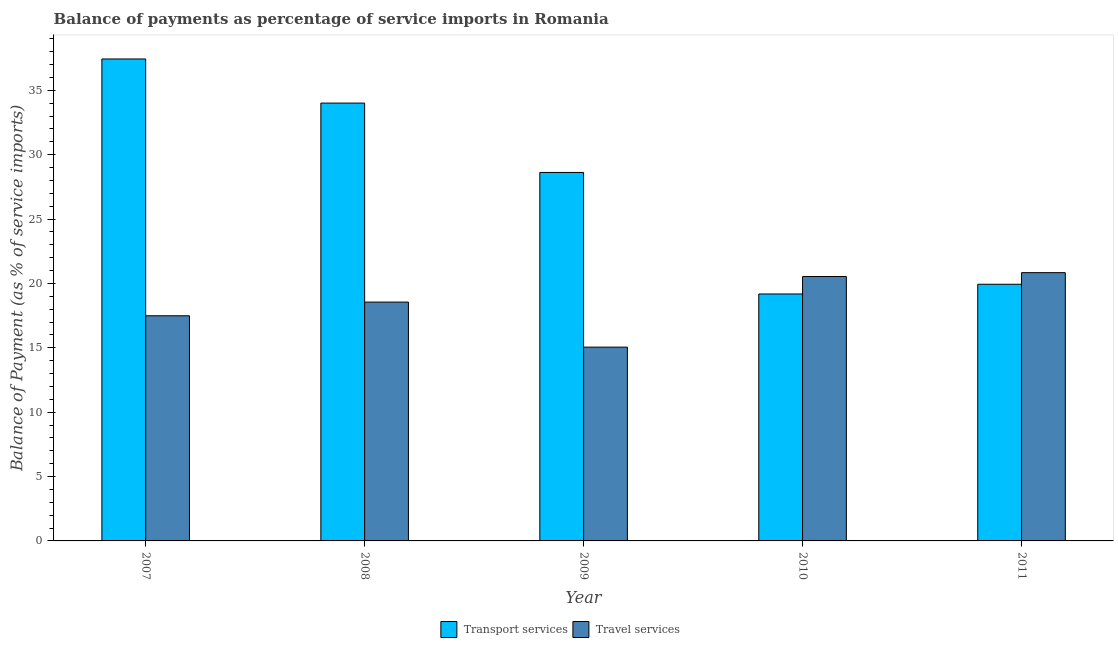How many different coloured bars are there?
Offer a very short reply. 2. How many groups of bars are there?
Offer a terse response. 5. Are the number of bars on each tick of the X-axis equal?
Make the answer very short. Yes. How many bars are there on the 4th tick from the left?
Keep it short and to the point. 2. How many bars are there on the 4th tick from the right?
Provide a short and direct response. 2. What is the label of the 5th group of bars from the left?
Provide a succinct answer. 2011. In how many cases, is the number of bars for a given year not equal to the number of legend labels?
Your answer should be very brief. 0. What is the balance of payments of transport services in 2011?
Provide a succinct answer. 19.94. Across all years, what is the maximum balance of payments of transport services?
Provide a short and direct response. 37.44. Across all years, what is the minimum balance of payments of travel services?
Offer a very short reply. 15.05. In which year was the balance of payments of travel services maximum?
Your answer should be compact. 2011. What is the total balance of payments of transport services in the graph?
Provide a short and direct response. 139.19. What is the difference between the balance of payments of travel services in 2008 and that in 2011?
Your answer should be very brief. -2.29. What is the difference between the balance of payments of transport services in 2010 and the balance of payments of travel services in 2009?
Your answer should be compact. -9.44. What is the average balance of payments of transport services per year?
Provide a short and direct response. 27.84. What is the ratio of the balance of payments of transport services in 2007 to that in 2011?
Your answer should be compact. 1.88. Is the difference between the balance of payments of travel services in 2008 and 2009 greater than the difference between the balance of payments of transport services in 2008 and 2009?
Offer a terse response. No. What is the difference between the highest and the second highest balance of payments of transport services?
Your answer should be very brief. 3.43. What is the difference between the highest and the lowest balance of payments of transport services?
Your answer should be very brief. 18.25. What does the 2nd bar from the left in 2011 represents?
Provide a short and direct response. Travel services. What does the 2nd bar from the right in 2009 represents?
Your response must be concise. Transport services. How many years are there in the graph?
Make the answer very short. 5. What is the difference between two consecutive major ticks on the Y-axis?
Ensure brevity in your answer.  5. Are the values on the major ticks of Y-axis written in scientific E-notation?
Ensure brevity in your answer.  No. Does the graph contain grids?
Your response must be concise. No. Where does the legend appear in the graph?
Provide a short and direct response. Bottom center. How are the legend labels stacked?
Provide a succinct answer. Horizontal. What is the title of the graph?
Make the answer very short. Balance of payments as percentage of service imports in Romania. What is the label or title of the X-axis?
Provide a short and direct response. Year. What is the label or title of the Y-axis?
Offer a terse response. Balance of Payment (as % of service imports). What is the Balance of Payment (as % of service imports) in Transport services in 2007?
Provide a short and direct response. 37.44. What is the Balance of Payment (as % of service imports) of Travel services in 2007?
Keep it short and to the point. 17.49. What is the Balance of Payment (as % of service imports) of Transport services in 2008?
Offer a terse response. 34.01. What is the Balance of Payment (as % of service imports) of Travel services in 2008?
Your answer should be very brief. 18.55. What is the Balance of Payment (as % of service imports) in Transport services in 2009?
Provide a short and direct response. 28.62. What is the Balance of Payment (as % of service imports) of Travel services in 2009?
Give a very brief answer. 15.05. What is the Balance of Payment (as % of service imports) of Transport services in 2010?
Your answer should be very brief. 19.18. What is the Balance of Payment (as % of service imports) of Travel services in 2010?
Give a very brief answer. 20.54. What is the Balance of Payment (as % of service imports) of Transport services in 2011?
Provide a succinct answer. 19.94. What is the Balance of Payment (as % of service imports) in Travel services in 2011?
Keep it short and to the point. 20.84. Across all years, what is the maximum Balance of Payment (as % of service imports) of Transport services?
Your response must be concise. 37.44. Across all years, what is the maximum Balance of Payment (as % of service imports) of Travel services?
Ensure brevity in your answer.  20.84. Across all years, what is the minimum Balance of Payment (as % of service imports) of Transport services?
Your response must be concise. 19.18. Across all years, what is the minimum Balance of Payment (as % of service imports) of Travel services?
Provide a short and direct response. 15.05. What is the total Balance of Payment (as % of service imports) in Transport services in the graph?
Keep it short and to the point. 139.19. What is the total Balance of Payment (as % of service imports) of Travel services in the graph?
Provide a succinct answer. 92.47. What is the difference between the Balance of Payment (as % of service imports) of Transport services in 2007 and that in 2008?
Keep it short and to the point. 3.43. What is the difference between the Balance of Payment (as % of service imports) of Travel services in 2007 and that in 2008?
Give a very brief answer. -1.06. What is the difference between the Balance of Payment (as % of service imports) of Transport services in 2007 and that in 2009?
Give a very brief answer. 8.81. What is the difference between the Balance of Payment (as % of service imports) in Travel services in 2007 and that in 2009?
Ensure brevity in your answer.  2.44. What is the difference between the Balance of Payment (as % of service imports) in Transport services in 2007 and that in 2010?
Offer a very short reply. 18.25. What is the difference between the Balance of Payment (as % of service imports) of Travel services in 2007 and that in 2010?
Make the answer very short. -3.05. What is the difference between the Balance of Payment (as % of service imports) in Transport services in 2007 and that in 2011?
Your answer should be compact. 17.5. What is the difference between the Balance of Payment (as % of service imports) of Travel services in 2007 and that in 2011?
Ensure brevity in your answer.  -3.35. What is the difference between the Balance of Payment (as % of service imports) of Transport services in 2008 and that in 2009?
Ensure brevity in your answer.  5.39. What is the difference between the Balance of Payment (as % of service imports) of Travel services in 2008 and that in 2009?
Your answer should be compact. 3.5. What is the difference between the Balance of Payment (as % of service imports) in Transport services in 2008 and that in 2010?
Offer a terse response. 14.83. What is the difference between the Balance of Payment (as % of service imports) of Travel services in 2008 and that in 2010?
Keep it short and to the point. -1.99. What is the difference between the Balance of Payment (as % of service imports) of Transport services in 2008 and that in 2011?
Your answer should be very brief. 14.07. What is the difference between the Balance of Payment (as % of service imports) of Travel services in 2008 and that in 2011?
Provide a succinct answer. -2.29. What is the difference between the Balance of Payment (as % of service imports) in Transport services in 2009 and that in 2010?
Provide a succinct answer. 9.44. What is the difference between the Balance of Payment (as % of service imports) of Travel services in 2009 and that in 2010?
Give a very brief answer. -5.48. What is the difference between the Balance of Payment (as % of service imports) of Transport services in 2009 and that in 2011?
Provide a succinct answer. 8.69. What is the difference between the Balance of Payment (as % of service imports) of Travel services in 2009 and that in 2011?
Give a very brief answer. -5.78. What is the difference between the Balance of Payment (as % of service imports) of Transport services in 2010 and that in 2011?
Provide a succinct answer. -0.75. What is the difference between the Balance of Payment (as % of service imports) of Travel services in 2010 and that in 2011?
Keep it short and to the point. -0.3. What is the difference between the Balance of Payment (as % of service imports) in Transport services in 2007 and the Balance of Payment (as % of service imports) in Travel services in 2008?
Offer a very short reply. 18.88. What is the difference between the Balance of Payment (as % of service imports) of Transport services in 2007 and the Balance of Payment (as % of service imports) of Travel services in 2009?
Keep it short and to the point. 22.38. What is the difference between the Balance of Payment (as % of service imports) in Transport services in 2007 and the Balance of Payment (as % of service imports) in Travel services in 2010?
Give a very brief answer. 16.9. What is the difference between the Balance of Payment (as % of service imports) in Transport services in 2007 and the Balance of Payment (as % of service imports) in Travel services in 2011?
Your response must be concise. 16.6. What is the difference between the Balance of Payment (as % of service imports) of Transport services in 2008 and the Balance of Payment (as % of service imports) of Travel services in 2009?
Offer a terse response. 18.96. What is the difference between the Balance of Payment (as % of service imports) in Transport services in 2008 and the Balance of Payment (as % of service imports) in Travel services in 2010?
Make the answer very short. 13.47. What is the difference between the Balance of Payment (as % of service imports) of Transport services in 2008 and the Balance of Payment (as % of service imports) of Travel services in 2011?
Offer a very short reply. 13.17. What is the difference between the Balance of Payment (as % of service imports) of Transport services in 2009 and the Balance of Payment (as % of service imports) of Travel services in 2010?
Give a very brief answer. 8.09. What is the difference between the Balance of Payment (as % of service imports) in Transport services in 2009 and the Balance of Payment (as % of service imports) in Travel services in 2011?
Your response must be concise. 7.79. What is the difference between the Balance of Payment (as % of service imports) of Transport services in 2010 and the Balance of Payment (as % of service imports) of Travel services in 2011?
Your answer should be very brief. -1.66. What is the average Balance of Payment (as % of service imports) in Transport services per year?
Your answer should be compact. 27.84. What is the average Balance of Payment (as % of service imports) in Travel services per year?
Keep it short and to the point. 18.49. In the year 2007, what is the difference between the Balance of Payment (as % of service imports) in Transport services and Balance of Payment (as % of service imports) in Travel services?
Ensure brevity in your answer.  19.95. In the year 2008, what is the difference between the Balance of Payment (as % of service imports) of Transport services and Balance of Payment (as % of service imports) of Travel services?
Keep it short and to the point. 15.46. In the year 2009, what is the difference between the Balance of Payment (as % of service imports) of Transport services and Balance of Payment (as % of service imports) of Travel services?
Keep it short and to the point. 13.57. In the year 2010, what is the difference between the Balance of Payment (as % of service imports) in Transport services and Balance of Payment (as % of service imports) in Travel services?
Ensure brevity in your answer.  -1.36. In the year 2011, what is the difference between the Balance of Payment (as % of service imports) of Transport services and Balance of Payment (as % of service imports) of Travel services?
Give a very brief answer. -0.9. What is the ratio of the Balance of Payment (as % of service imports) of Transport services in 2007 to that in 2008?
Offer a very short reply. 1.1. What is the ratio of the Balance of Payment (as % of service imports) in Travel services in 2007 to that in 2008?
Provide a succinct answer. 0.94. What is the ratio of the Balance of Payment (as % of service imports) of Transport services in 2007 to that in 2009?
Offer a terse response. 1.31. What is the ratio of the Balance of Payment (as % of service imports) of Travel services in 2007 to that in 2009?
Keep it short and to the point. 1.16. What is the ratio of the Balance of Payment (as % of service imports) of Transport services in 2007 to that in 2010?
Provide a short and direct response. 1.95. What is the ratio of the Balance of Payment (as % of service imports) of Travel services in 2007 to that in 2010?
Offer a very short reply. 0.85. What is the ratio of the Balance of Payment (as % of service imports) in Transport services in 2007 to that in 2011?
Keep it short and to the point. 1.88. What is the ratio of the Balance of Payment (as % of service imports) of Travel services in 2007 to that in 2011?
Give a very brief answer. 0.84. What is the ratio of the Balance of Payment (as % of service imports) in Transport services in 2008 to that in 2009?
Give a very brief answer. 1.19. What is the ratio of the Balance of Payment (as % of service imports) of Travel services in 2008 to that in 2009?
Offer a terse response. 1.23. What is the ratio of the Balance of Payment (as % of service imports) of Transport services in 2008 to that in 2010?
Make the answer very short. 1.77. What is the ratio of the Balance of Payment (as % of service imports) in Travel services in 2008 to that in 2010?
Keep it short and to the point. 0.9. What is the ratio of the Balance of Payment (as % of service imports) in Transport services in 2008 to that in 2011?
Your response must be concise. 1.71. What is the ratio of the Balance of Payment (as % of service imports) in Travel services in 2008 to that in 2011?
Make the answer very short. 0.89. What is the ratio of the Balance of Payment (as % of service imports) in Transport services in 2009 to that in 2010?
Your answer should be very brief. 1.49. What is the ratio of the Balance of Payment (as % of service imports) in Travel services in 2009 to that in 2010?
Your response must be concise. 0.73. What is the ratio of the Balance of Payment (as % of service imports) of Transport services in 2009 to that in 2011?
Your answer should be very brief. 1.44. What is the ratio of the Balance of Payment (as % of service imports) in Travel services in 2009 to that in 2011?
Provide a succinct answer. 0.72. What is the ratio of the Balance of Payment (as % of service imports) in Transport services in 2010 to that in 2011?
Make the answer very short. 0.96. What is the ratio of the Balance of Payment (as % of service imports) of Travel services in 2010 to that in 2011?
Your response must be concise. 0.99. What is the difference between the highest and the second highest Balance of Payment (as % of service imports) in Transport services?
Provide a succinct answer. 3.43. What is the difference between the highest and the second highest Balance of Payment (as % of service imports) in Travel services?
Your answer should be compact. 0.3. What is the difference between the highest and the lowest Balance of Payment (as % of service imports) of Transport services?
Ensure brevity in your answer.  18.25. What is the difference between the highest and the lowest Balance of Payment (as % of service imports) of Travel services?
Keep it short and to the point. 5.78. 